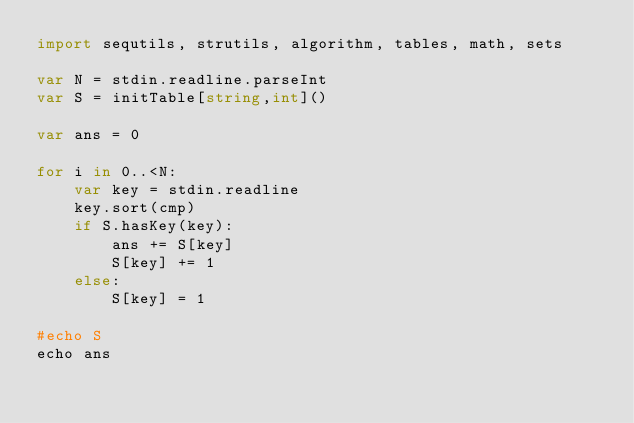Convert code to text. <code><loc_0><loc_0><loc_500><loc_500><_Nim_>import sequtils, strutils, algorithm, tables, math, sets

var N = stdin.readline.parseInt
var S = initTable[string,int]()

var ans = 0

for i in 0..<N:
    var key = stdin.readline
    key.sort(cmp)
    if S.hasKey(key):
        ans += S[key]
        S[key] += 1
    else:
        S[key] = 1

#echo S
echo ans
</code> 